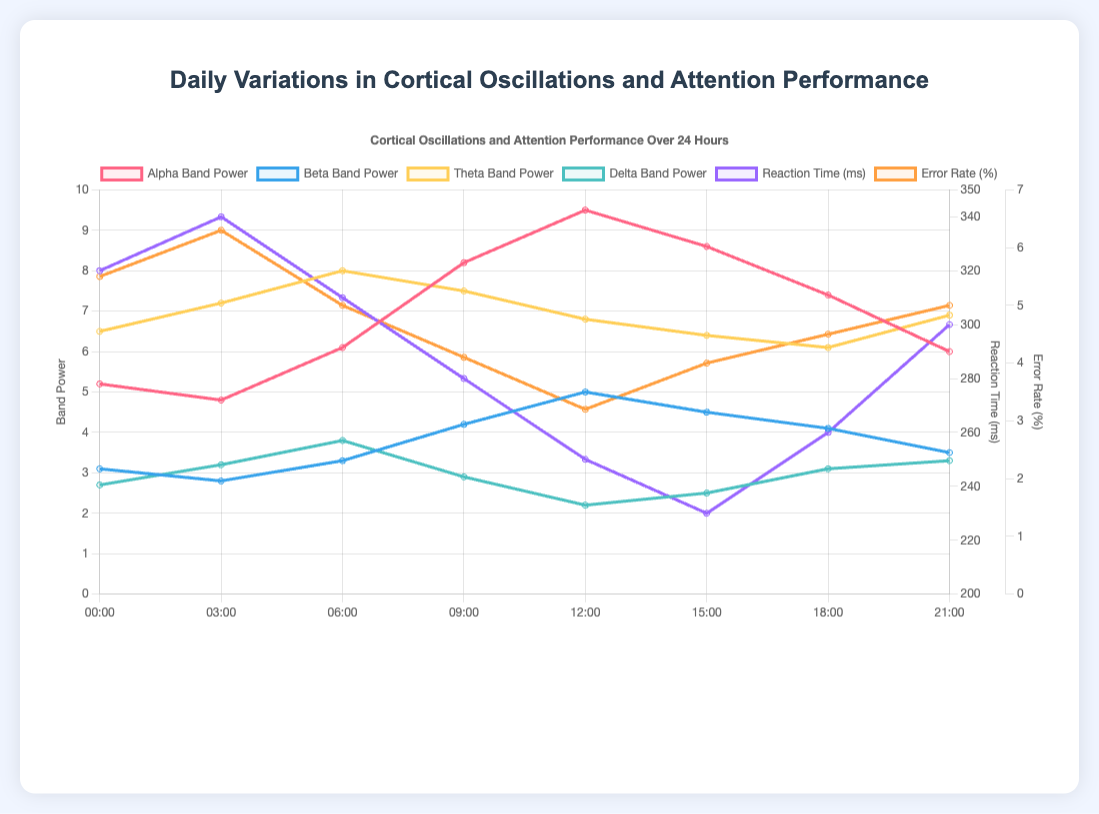Which time point has the highest alpha band power? To find the highest alpha band power, we look at the 'Alpha Band Power' line in the line plot and identify the peak value. The highest value is at 12:00 with alpha band power 9.5
Answer: 12:00 How does the reaction time at 06:00 compare to the reaction time at 18:00? To compare the reaction times at 06:00 and 18:00, we look at the 'Reaction Time (ms)' line in the plot. At 06:00, the reaction time is 310 ms, and at 18:00, it is 260 ms. 310 ms is higher than 260 ms
Answer: 310 ms is higher than 260 ms What is the sum of the delta band power values at 00:00 and 21:00? To find the sum of delta band power values at 00:00 and 21:00, we look at the 'Delta Band Power' line in the plot. The values are 2.7 and 3.3, respectively. So, the sum is 2.7 + 3.3 = 6.0
Answer: 6.0 During which time interval does the error rate percentage decrease the most? To identify the largest decrease in error rate percentage, we look at the 'Error Rate (%)' line and find the steepest downward slope. The largest decrease occurs from 03:00 to 09:00, where it goes from 6.3% to 4.1%
Answer: 03:00 to 09:00 What is the average beta band power over the entire day? To find the average beta band power, we sum up the beta values at all time points and divide by the number of time points: (3.1 + 2.8 + 3.3 + 4.2 + 5.0 + 4.5 + 4.1 + 3.5)/8. The calculation is: (3.1 + 2.8 + 3.3 + 4.2 + 5.0 + 4.5 + 4.1 + 3.5) = 30.5; 30.5/8 = 3.81
Answer: 3.81 Which band power has the lowest value at 12:00 and what is it? To determine the lowest band power at 12:00, we refer to the values at this time point for each line representing different bands. Alpha is 9.5, beta is 5.0, theta is 6.8, and delta is 2.2. The lowest value is delta at 2.2
Answer: Delta at 2.2 